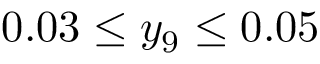Convert formula to latex. <formula><loc_0><loc_0><loc_500><loc_500>0 . 0 3 \leq y _ { 9 } \leq 0 . 0 5</formula> 